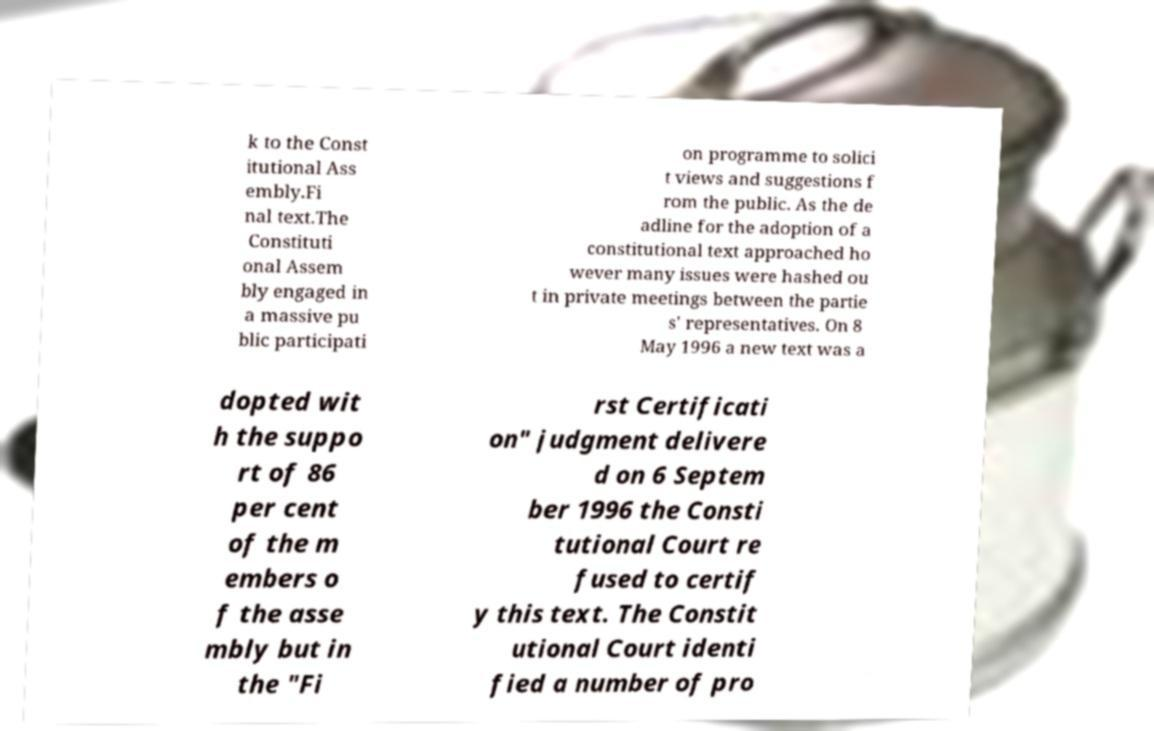What messages or text are displayed in this image? I need them in a readable, typed format. k to the Const itutional Ass embly.Fi nal text.The Constituti onal Assem bly engaged in a massive pu blic participati on programme to solici t views and suggestions f rom the public. As the de adline for the adoption of a constitutional text approached ho wever many issues were hashed ou t in private meetings between the partie s' representatives. On 8 May 1996 a new text was a dopted wit h the suppo rt of 86 per cent of the m embers o f the asse mbly but in the "Fi rst Certificati on" judgment delivere d on 6 Septem ber 1996 the Consti tutional Court re fused to certif y this text. The Constit utional Court identi fied a number of pro 